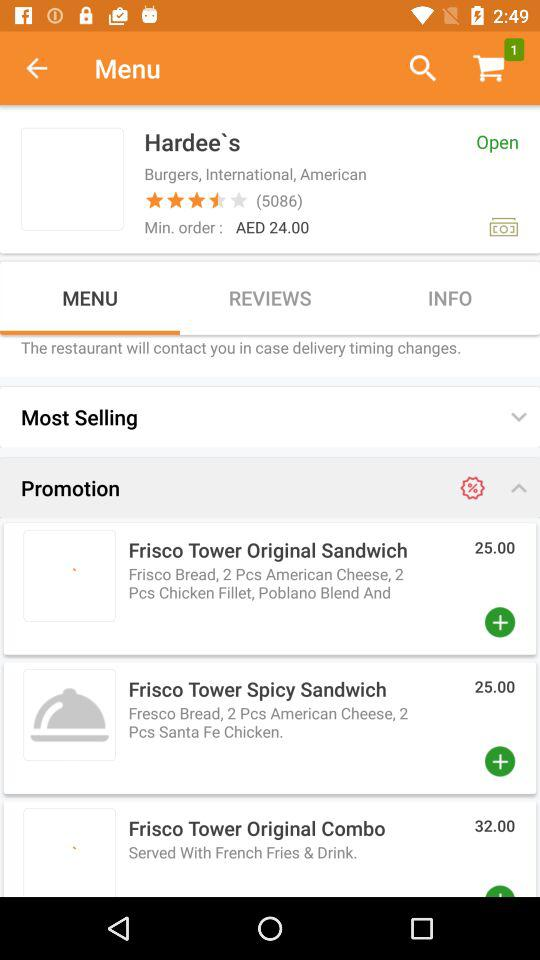How many stars did the restaurant get out of 5? The restaurant got 4.5 stars out of 5. 